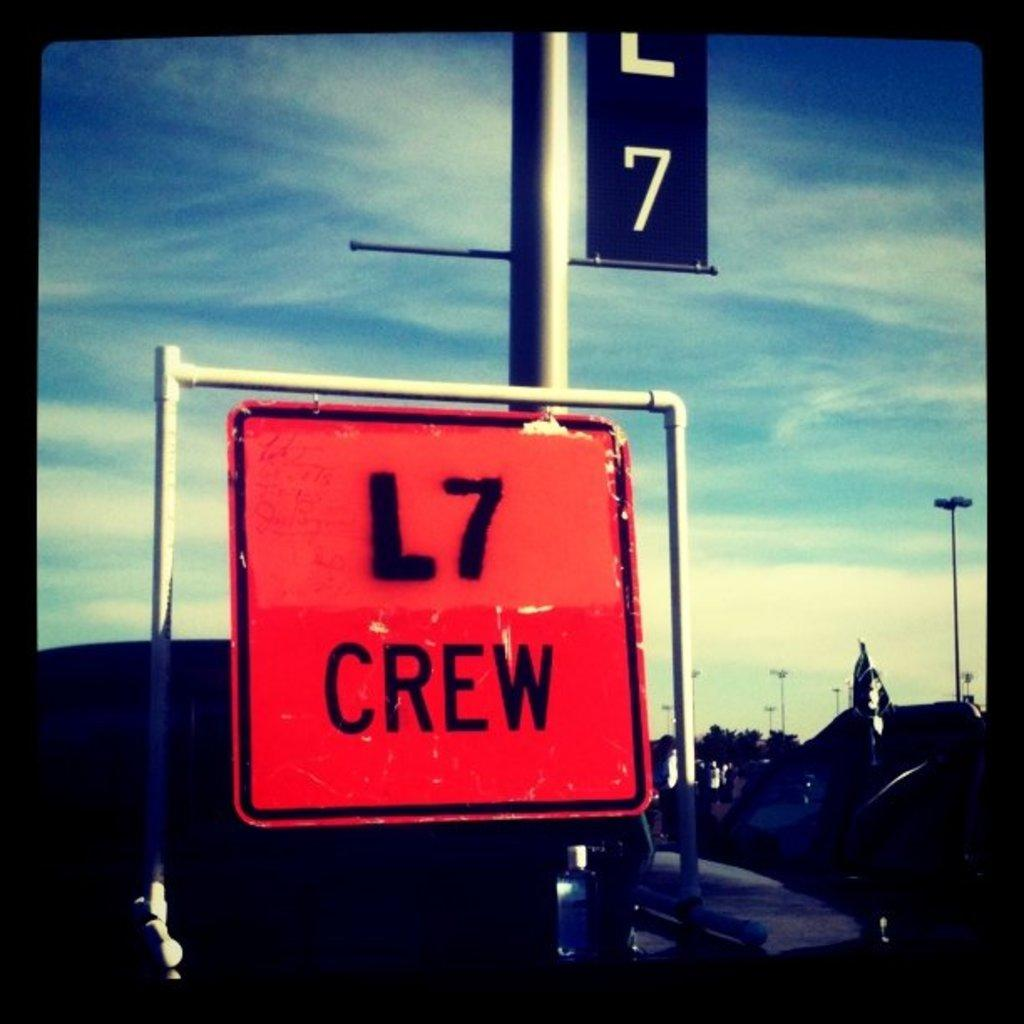<image>
Write a terse but informative summary of the picture. An outdoor orange metal sign with L7 crew written on it. 